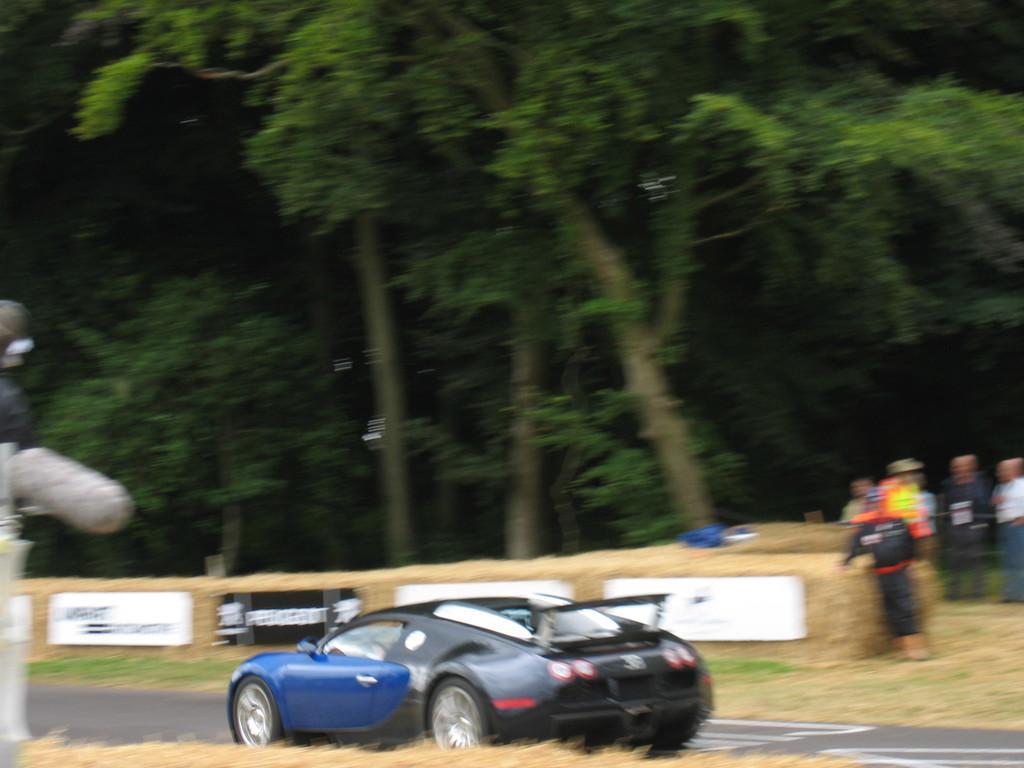Describe this image in one or two sentences. In this image there is a vehicle on the road, there are few people few trees, some boards attached to the wall and some objects on the wall. 